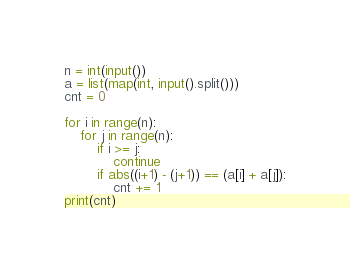<code> <loc_0><loc_0><loc_500><loc_500><_Python_>n = int(input())
a = list(map(int, input().split()))
cnt = 0

for i in range(n):
    for j in range(n):
        if i >= j:
            continue
        if abs((i+1) - (j+1)) == (a[i] + a[j]):
            cnt += 1
print(cnt)</code> 